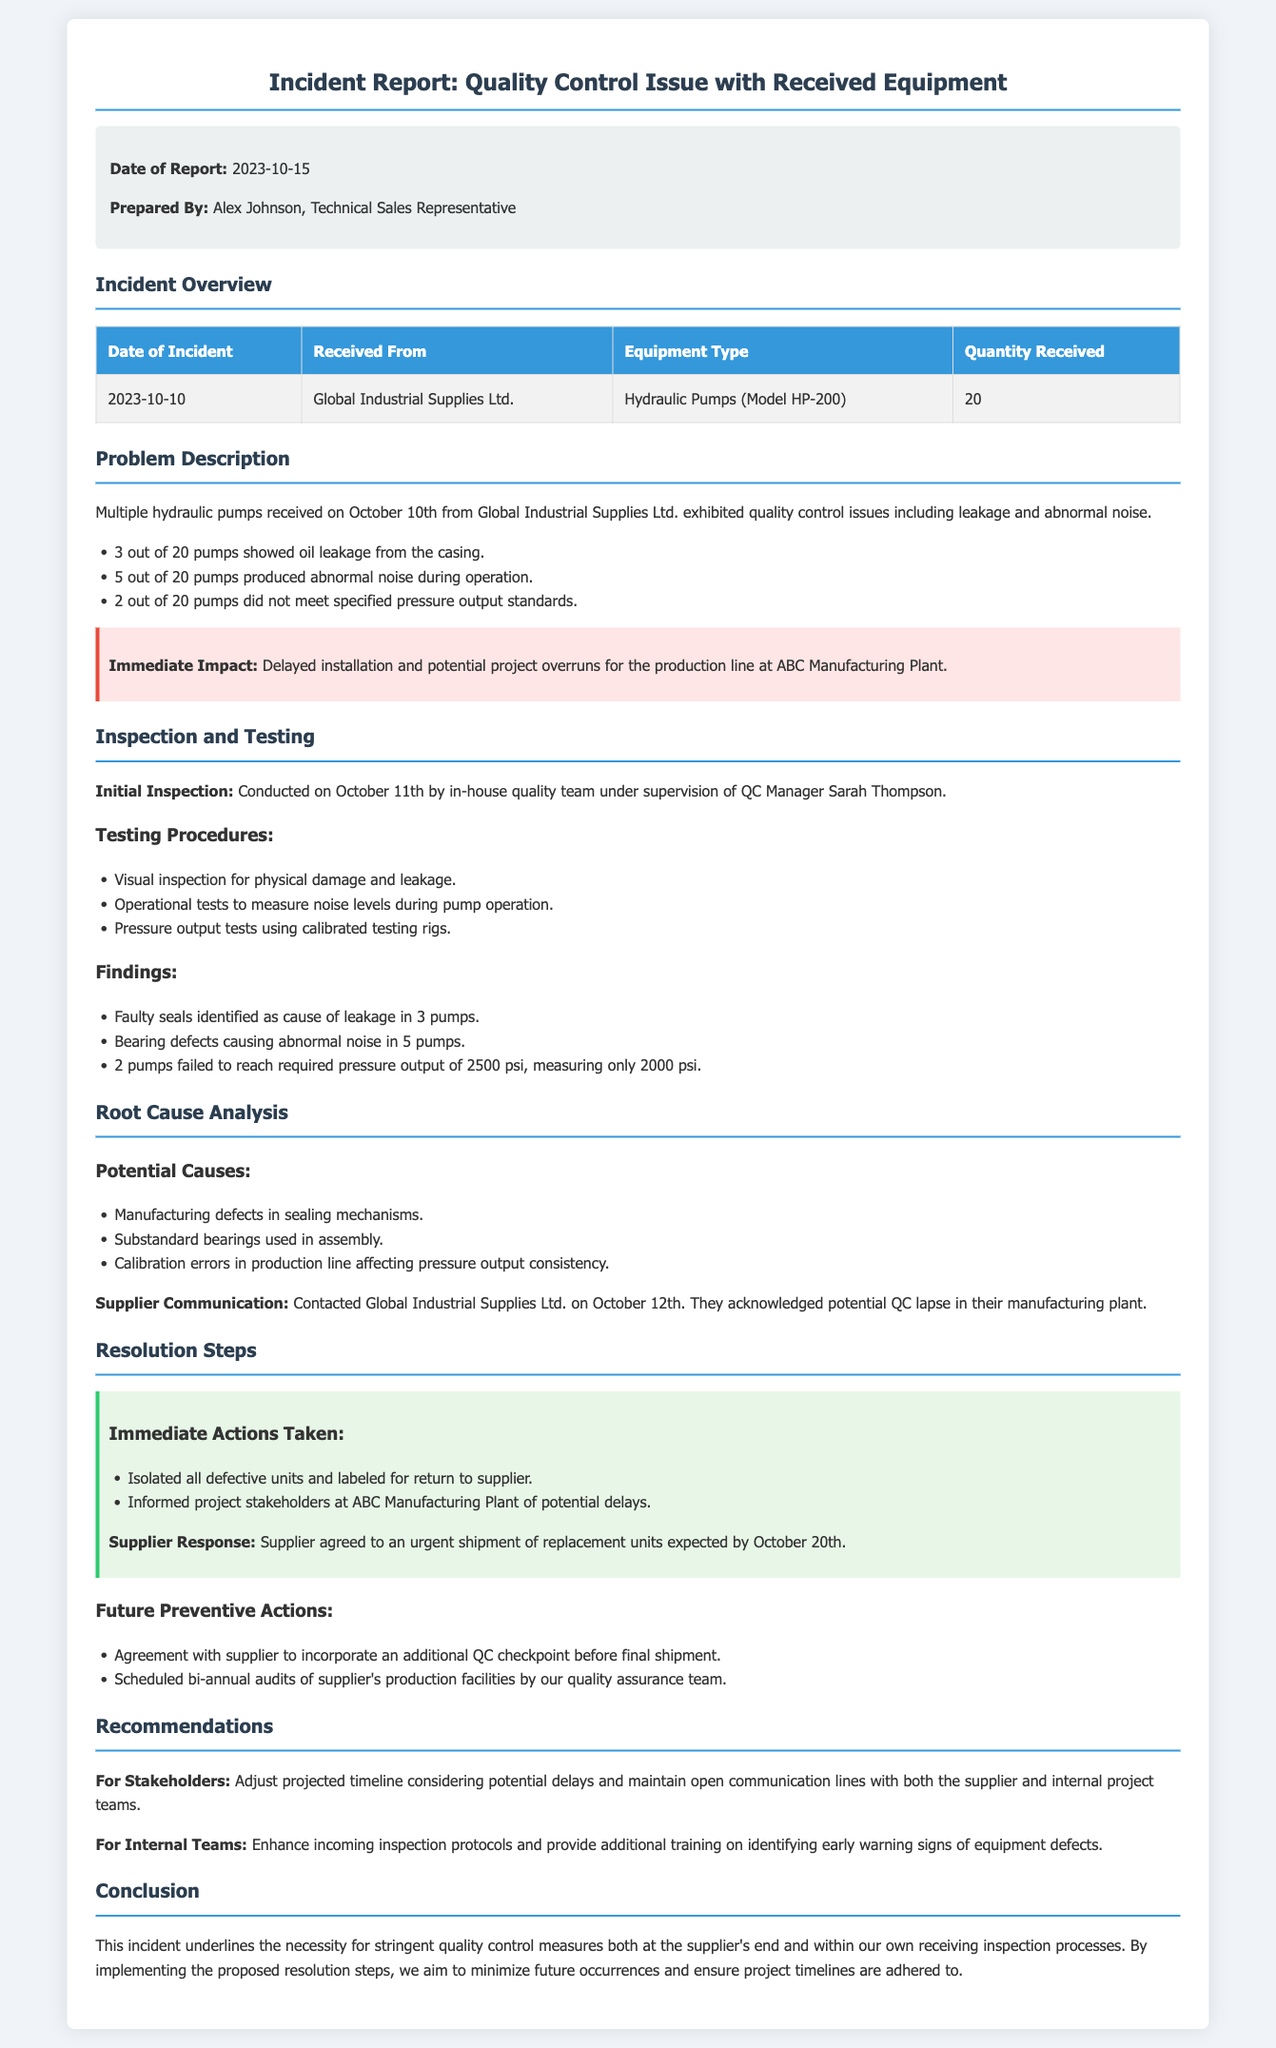What is the date of the incident? The date of the incident is mentioned in the incident overview section of the document.
Answer: 2023-10-10 Who prepared the incident report? The report indicates who prepared it in the meta info section.
Answer: Alex Johnson How many hydraulic pumps showed oil leakage? The document specifies the number of pumps with leakage in the problem description.
Answer: 3 What is the specified pressure output standard for the pumps? The required pressure output standard is mentioned in the findings section of the inspection.
Answer: 2500 psi What immediate impact did the quality control issue have? The immediate impact is described in a dedicated highlight section.
Answer: Delayed installation What corrective action did the supplier agree to? The supplier's response section outlines the actions they agreed to take.
Answer: Urgent shipment of replacement units How many pumps produced abnormal noise during operation? The problem description lists the number of pumps that generated abnormal noise.
Answer: 5 What is the root cause of the leakage identified? The findings from the inspection detail the cause of the leakage.
Answer: Faulty seals What future preventive action involves scheduled audits? The resolution steps mention a specific preventive action involving audits.
Answer: Bi-annual audits 